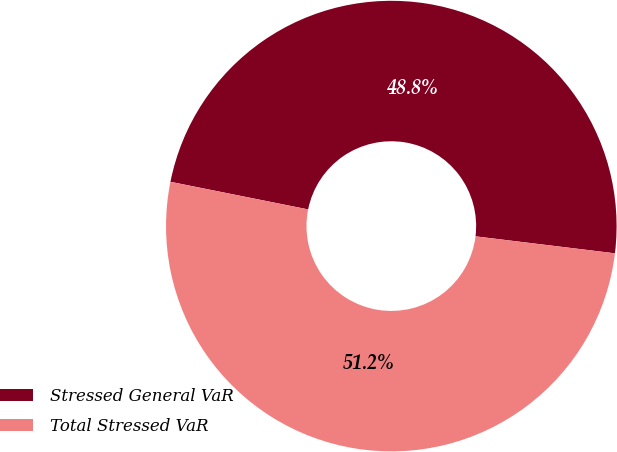<chart> <loc_0><loc_0><loc_500><loc_500><pie_chart><fcel>Stressed General VaR<fcel>Total Stressed VaR<nl><fcel>48.78%<fcel>51.22%<nl></chart> 